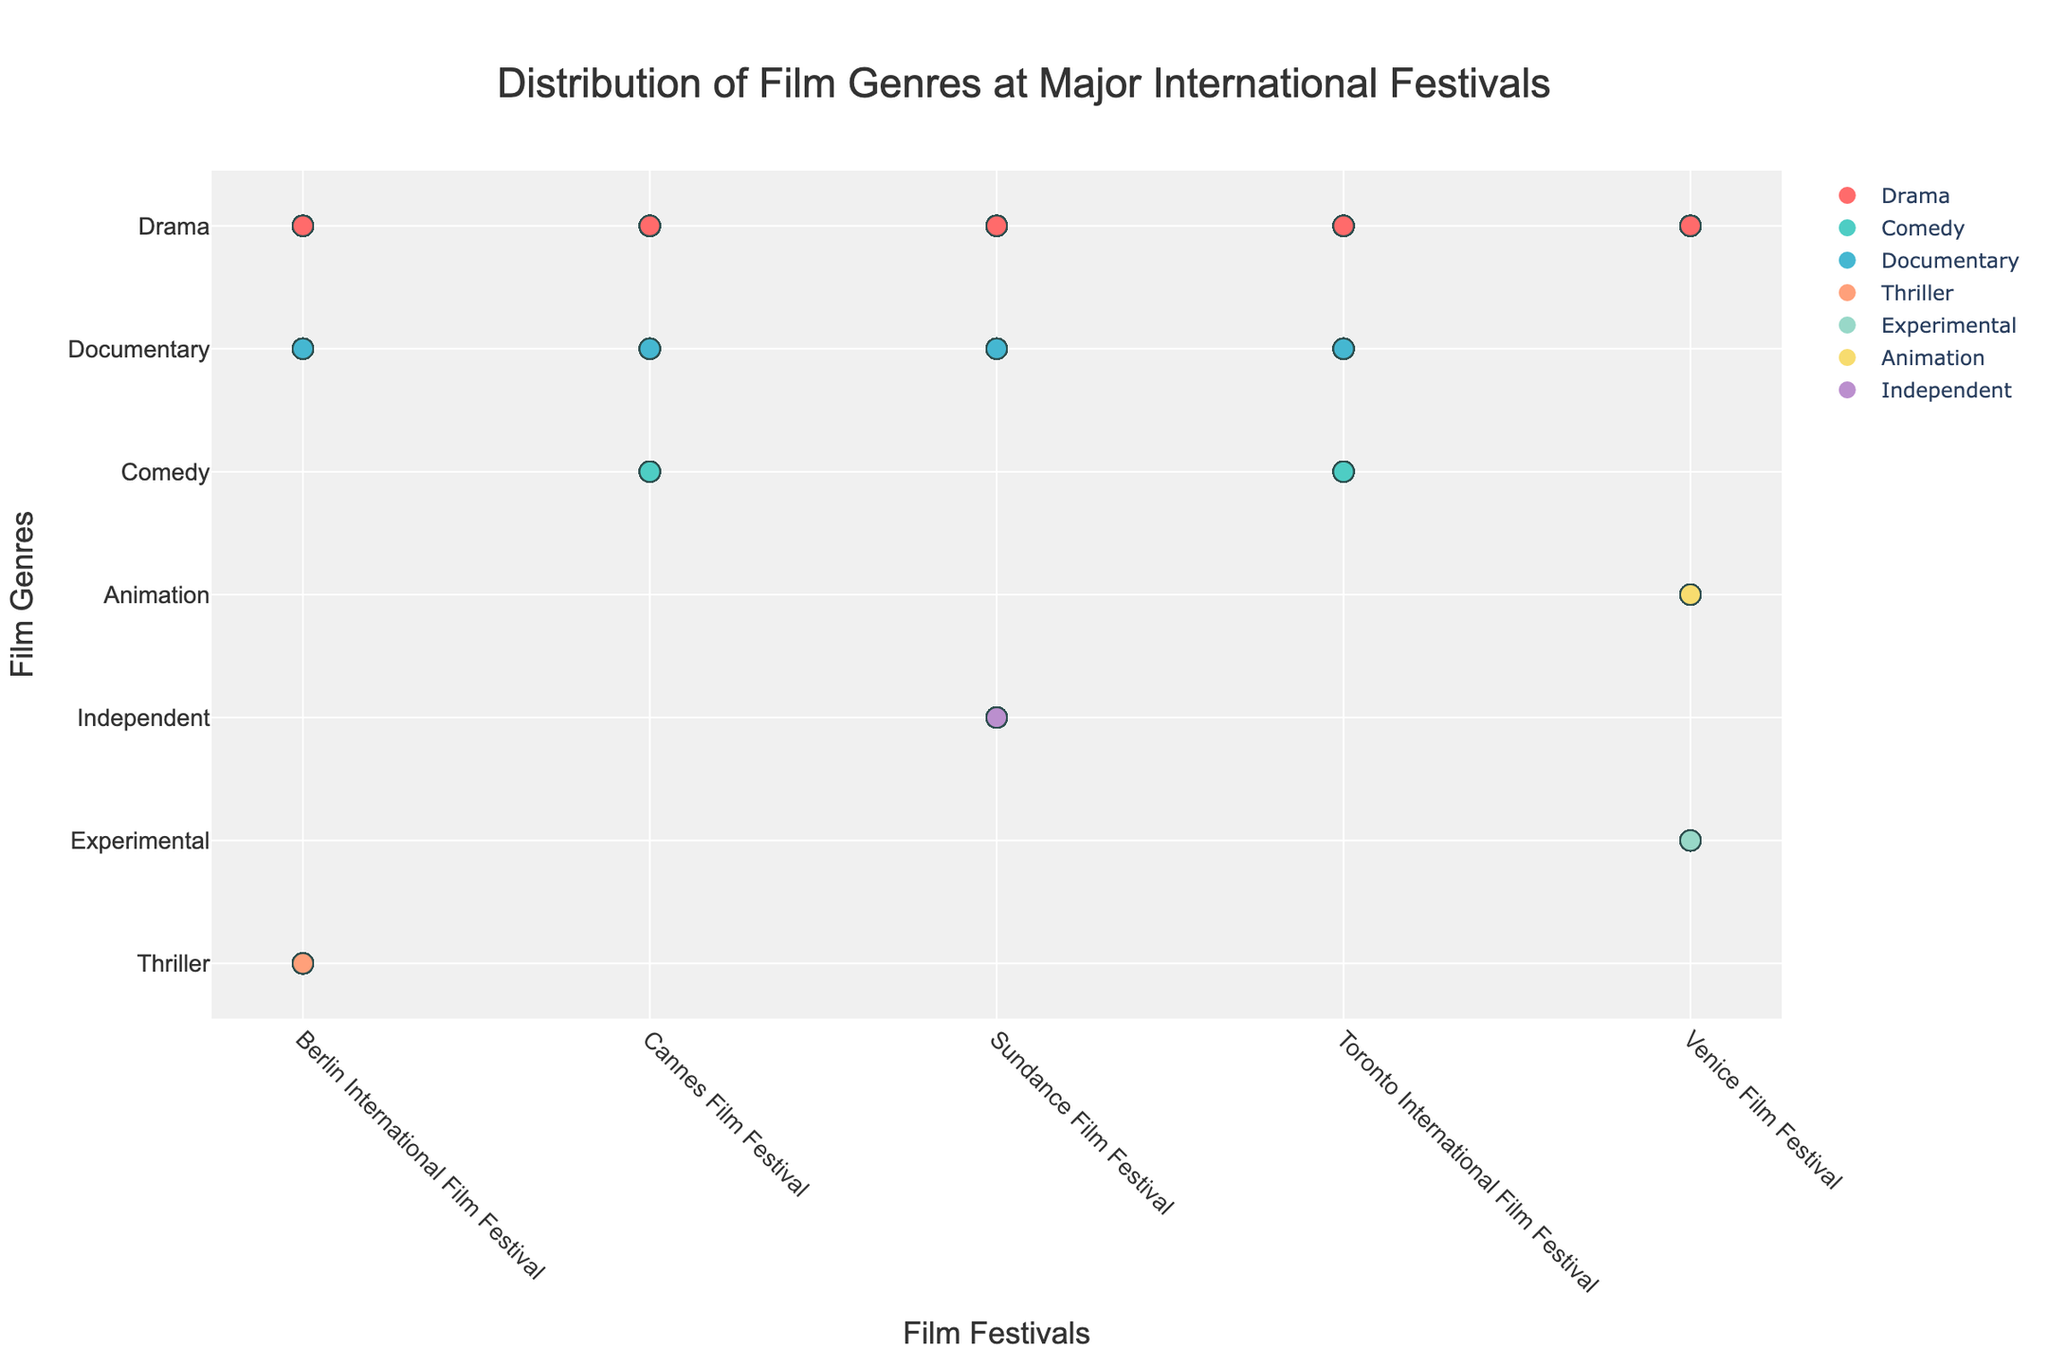what is the title of the plot? The title can be found at the top of the plot. It is usually larger than other texts and provides a summary of what the plot is about. In this case, the title reads 'Distribution of Film Genres at Major International Festivals.'
Answer: Distribution of Film Genres at Major International Festivals what are the colorful circles representing in the plot? The colorful circles in the plot represent individual films of different genres. Each color corresponds to a specific genre as defined in the legend of the plot.
Answer: Films of different genres which genre has the most films accepted at the Cannes Film Festival? To find this, we need to look at the Cannes Film Festival column and count the number of circles for each genre. Drama has the most circles, indicating it has the most films accepted.
Answer: Drama What is the total number of Documentary films accepted across all festivals? Sum the number of Documentary films from each festival. The counts are 20 (Cannes Film Festival) + 30 (Berlin International Film Festival) + 30 (Toronto International Film Festival) + 25 (Sundance Film Festival). Therefore, the total is 20 + 30 + 30 + 25 = 105.
Answer: 105 how do the numbers of Drama films accepted at the Berlin International Film Festival compare to the Venice Film Festival? Count the Drama circles for each festival. Berlin International Film Festival has 45 Drama films, while Venice Film Festival has 40. Therefore, Berlin International has 5 more Drama films accepted than Venice Film Festival.
Answer: Berlin International has 5 more how does the diversity of genres accepted at Sundance Film Festival compare to Cannes Film Festival? Evaluate the number of distinct genres for each festival. Sundance Film Festival has Drama, Independent, and Documentary, while Cannes Film Festival has Drama, Comedy, and Documentary. Both festivals have three distinct genres, indicating they have similar genre diversity.
Answer: Similar genre diversity which festival has the highest number of accepted Independent films? Look at the Independent genre markers across all festivals. Only the Sundance Film Festival has Independent films, with a count of 35.
Answer: Sundance Film Festival which genre appeared the least at Venice Film Festival? Count the circles for each genre at Venice Film Festival. Experimental has 15, Animation has 20, Drama has 40. Experimental has the least number of films accepted.
Answer: Experimental considering only the Toronto International Film Festival, how many more Comedy films were accepted compared to Drama films? From the Toronto International Film Festival, Comedy has 25 films, and Drama has 35. There are 35 - 25 = 10 more Drama films accepted than Comedy films.
Answer: 10 what is the average number of films accepted per genre at Berlin International Film Festival? Sum the number of all films accepted at Berlin International Film Festival and divide by the number of genres. The counts are 45 (Drama) + 25 (Thriller) + 30 (Documentary). Total is 100. There are 3 genres. The average is 100 / 3 = 33.33.
Answer: 33.33 